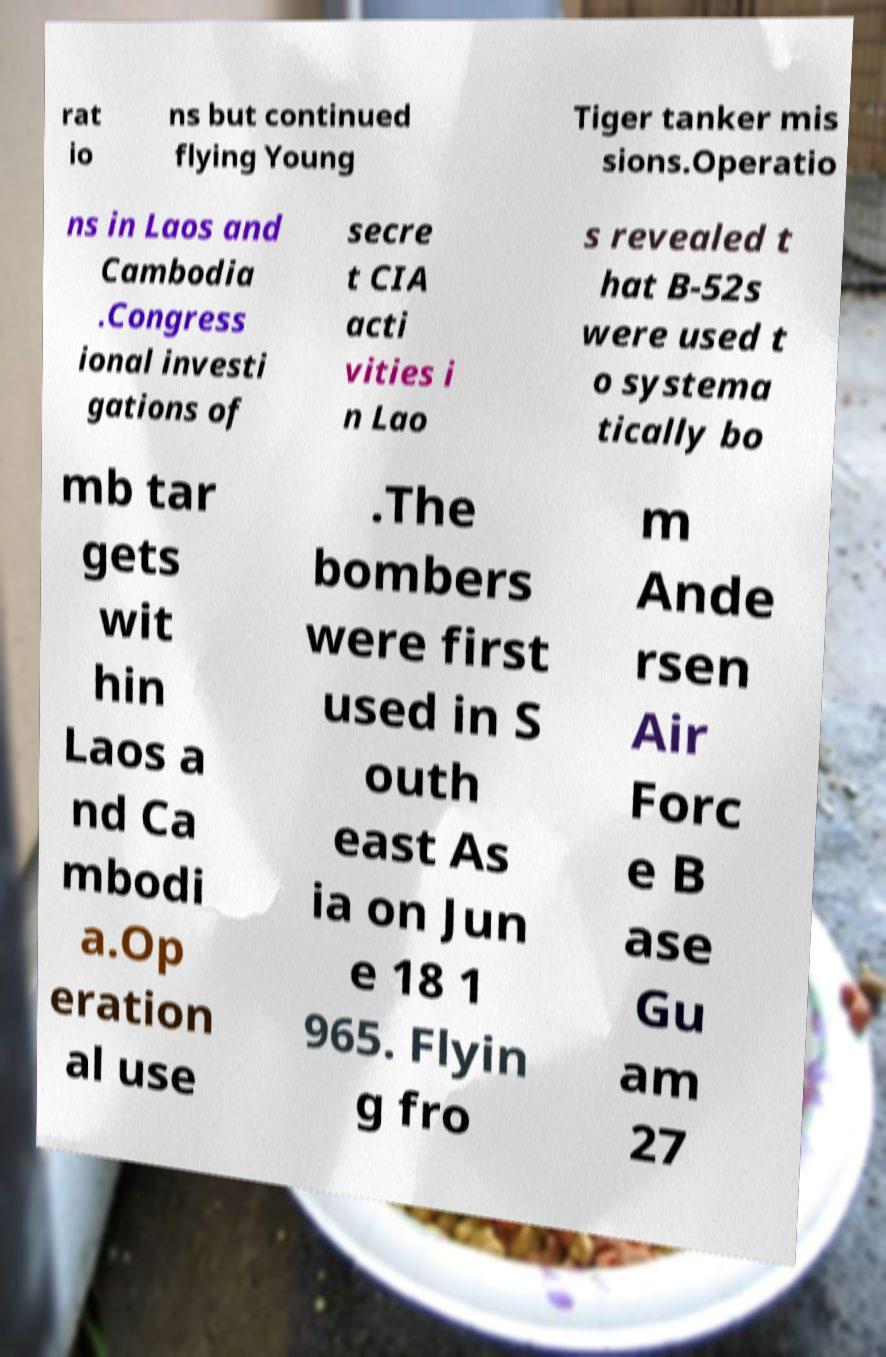What messages or text are displayed in this image? I need them in a readable, typed format. rat io ns but continued flying Young Tiger tanker mis sions.Operatio ns in Laos and Cambodia .Congress ional investi gations of secre t CIA acti vities i n Lao s revealed t hat B-52s were used t o systema tically bo mb tar gets wit hin Laos a nd Ca mbodi a.Op eration al use .The bombers were first used in S outh east As ia on Jun e 18 1 965. Flyin g fro m Ande rsen Air Forc e B ase Gu am 27 